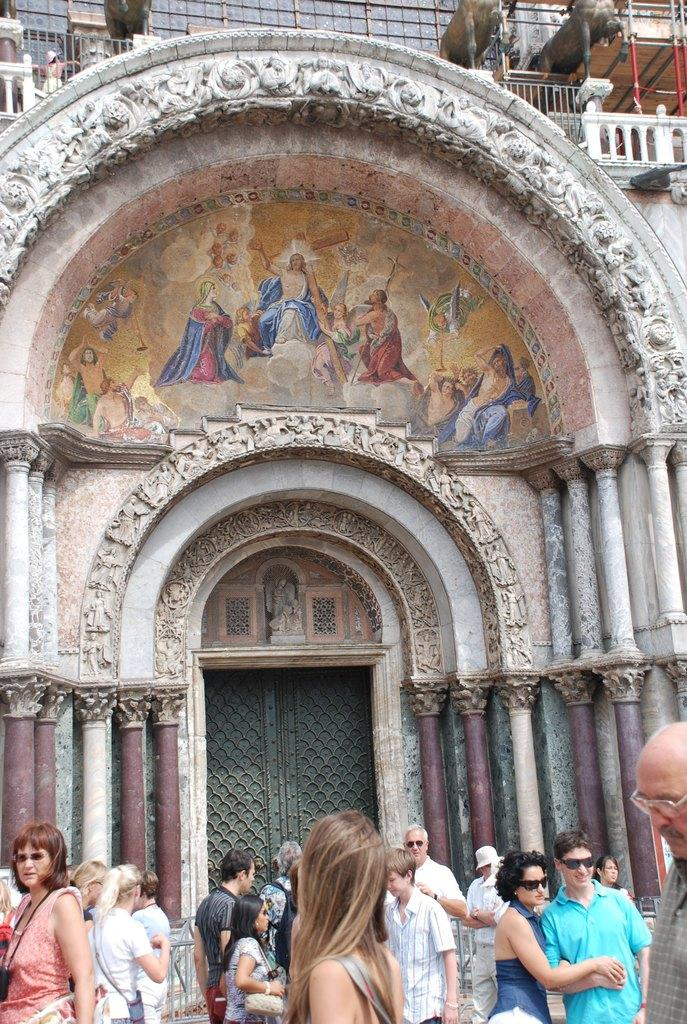How many people are in the image? There is a group of people in the image, but the exact number cannot be determined from the provided facts. What architectural features can be seen in the image? There are pillars and doors visible in the image. What type of artwork is present in the image? There is a painting on the wall in the image. What other objects can be seen in the image? There are some objects in the image, but their specific nature cannot be determined from the provided facts. What verse is being recited by the people in the image? There is no mention of any verse or recitation in the image, so it cannot be determined from the provided facts. What type of teeth can be seen on the statues in the image? There are no teeth visible on the statues in the image, as statues typically do not have teeth. 